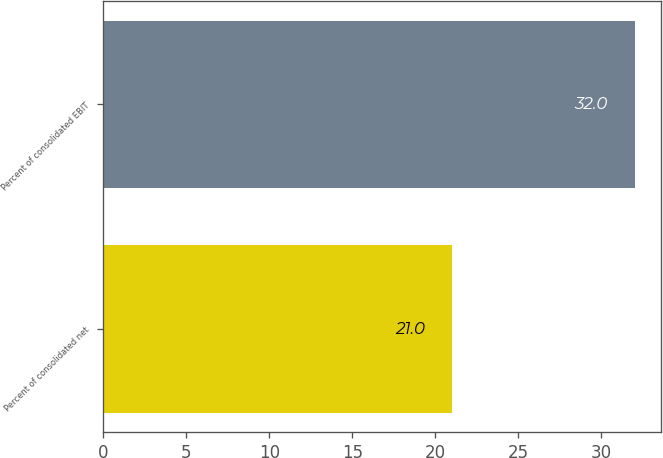Convert chart to OTSL. <chart><loc_0><loc_0><loc_500><loc_500><bar_chart><fcel>Percent of consolidated net<fcel>Percent of consolidated EBIT<nl><fcel>21<fcel>32<nl></chart> 